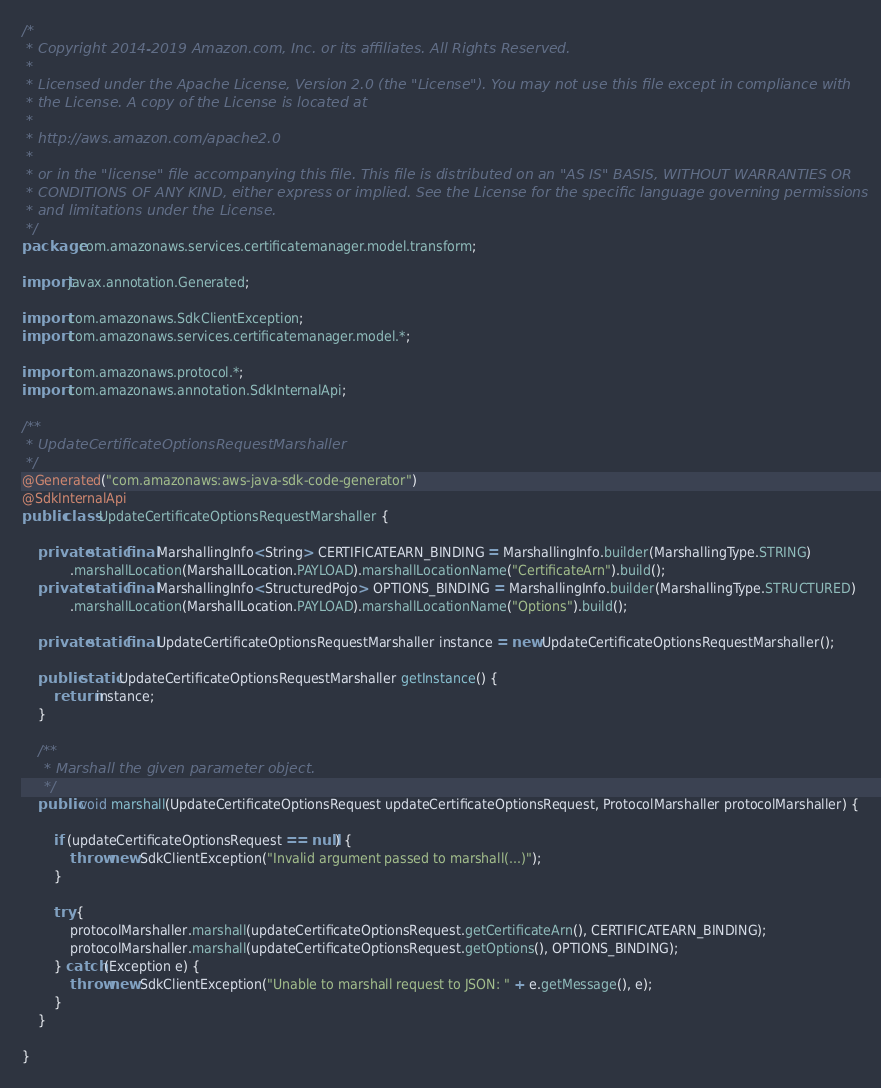Convert code to text. <code><loc_0><loc_0><loc_500><loc_500><_Java_>/*
 * Copyright 2014-2019 Amazon.com, Inc. or its affiliates. All Rights Reserved.
 * 
 * Licensed under the Apache License, Version 2.0 (the "License"). You may not use this file except in compliance with
 * the License. A copy of the License is located at
 * 
 * http://aws.amazon.com/apache2.0
 * 
 * or in the "license" file accompanying this file. This file is distributed on an "AS IS" BASIS, WITHOUT WARRANTIES OR
 * CONDITIONS OF ANY KIND, either express or implied. See the License for the specific language governing permissions
 * and limitations under the License.
 */
package com.amazonaws.services.certificatemanager.model.transform;

import javax.annotation.Generated;

import com.amazonaws.SdkClientException;
import com.amazonaws.services.certificatemanager.model.*;

import com.amazonaws.protocol.*;
import com.amazonaws.annotation.SdkInternalApi;

/**
 * UpdateCertificateOptionsRequestMarshaller
 */
@Generated("com.amazonaws:aws-java-sdk-code-generator")
@SdkInternalApi
public class UpdateCertificateOptionsRequestMarshaller {

    private static final MarshallingInfo<String> CERTIFICATEARN_BINDING = MarshallingInfo.builder(MarshallingType.STRING)
            .marshallLocation(MarshallLocation.PAYLOAD).marshallLocationName("CertificateArn").build();
    private static final MarshallingInfo<StructuredPojo> OPTIONS_BINDING = MarshallingInfo.builder(MarshallingType.STRUCTURED)
            .marshallLocation(MarshallLocation.PAYLOAD).marshallLocationName("Options").build();

    private static final UpdateCertificateOptionsRequestMarshaller instance = new UpdateCertificateOptionsRequestMarshaller();

    public static UpdateCertificateOptionsRequestMarshaller getInstance() {
        return instance;
    }

    /**
     * Marshall the given parameter object.
     */
    public void marshall(UpdateCertificateOptionsRequest updateCertificateOptionsRequest, ProtocolMarshaller protocolMarshaller) {

        if (updateCertificateOptionsRequest == null) {
            throw new SdkClientException("Invalid argument passed to marshall(...)");
        }

        try {
            protocolMarshaller.marshall(updateCertificateOptionsRequest.getCertificateArn(), CERTIFICATEARN_BINDING);
            protocolMarshaller.marshall(updateCertificateOptionsRequest.getOptions(), OPTIONS_BINDING);
        } catch (Exception e) {
            throw new SdkClientException("Unable to marshall request to JSON: " + e.getMessage(), e);
        }
    }

}
</code> 